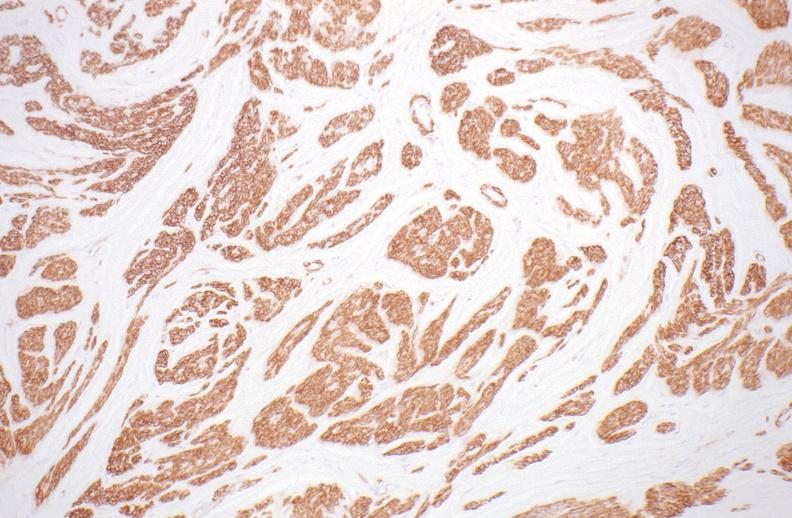where is this from?
Answer the question using a single word or phrase. Female reproductive system 